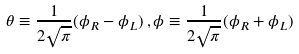<formula> <loc_0><loc_0><loc_500><loc_500>\theta \equiv \frac { 1 } { 2 \sqrt { \pi } } ( \phi _ { R } - \phi _ { L } ) \, , \phi \equiv \frac { 1 } { 2 \sqrt { \pi } } ( \phi _ { R } + \phi _ { L } )</formula> 